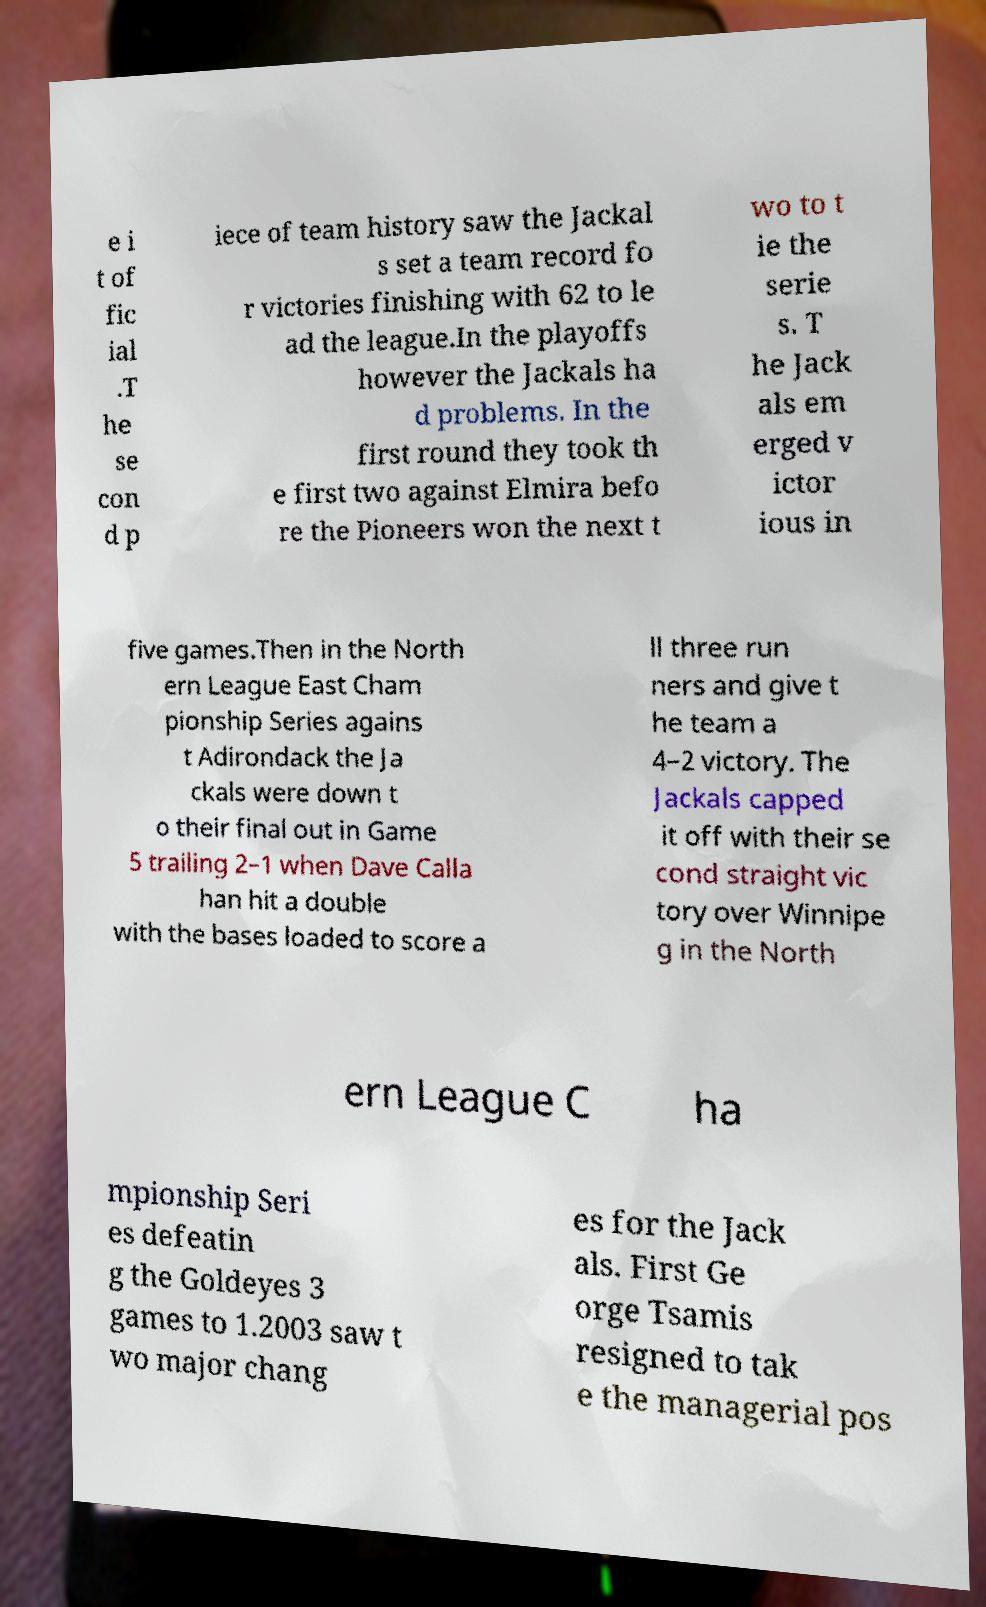Could you assist in decoding the text presented in this image and type it out clearly? e i t of fic ial .T he se con d p iece of team history saw the Jackal s set a team record fo r victories finishing with 62 to le ad the league.In the playoffs however the Jackals ha d problems. In the first round they took th e first two against Elmira befo re the Pioneers won the next t wo to t ie the serie s. T he Jack als em erged v ictor ious in five games.Then in the North ern League East Cham pionship Series agains t Adirondack the Ja ckals were down t o their final out in Game 5 trailing 2–1 when Dave Calla han hit a double with the bases loaded to score a ll three run ners and give t he team a 4–2 victory. The Jackals capped it off with their se cond straight vic tory over Winnipe g in the North ern League C ha mpionship Seri es defeatin g the Goldeyes 3 games to 1.2003 saw t wo major chang es for the Jack als. First Ge orge Tsamis resigned to tak e the managerial pos 